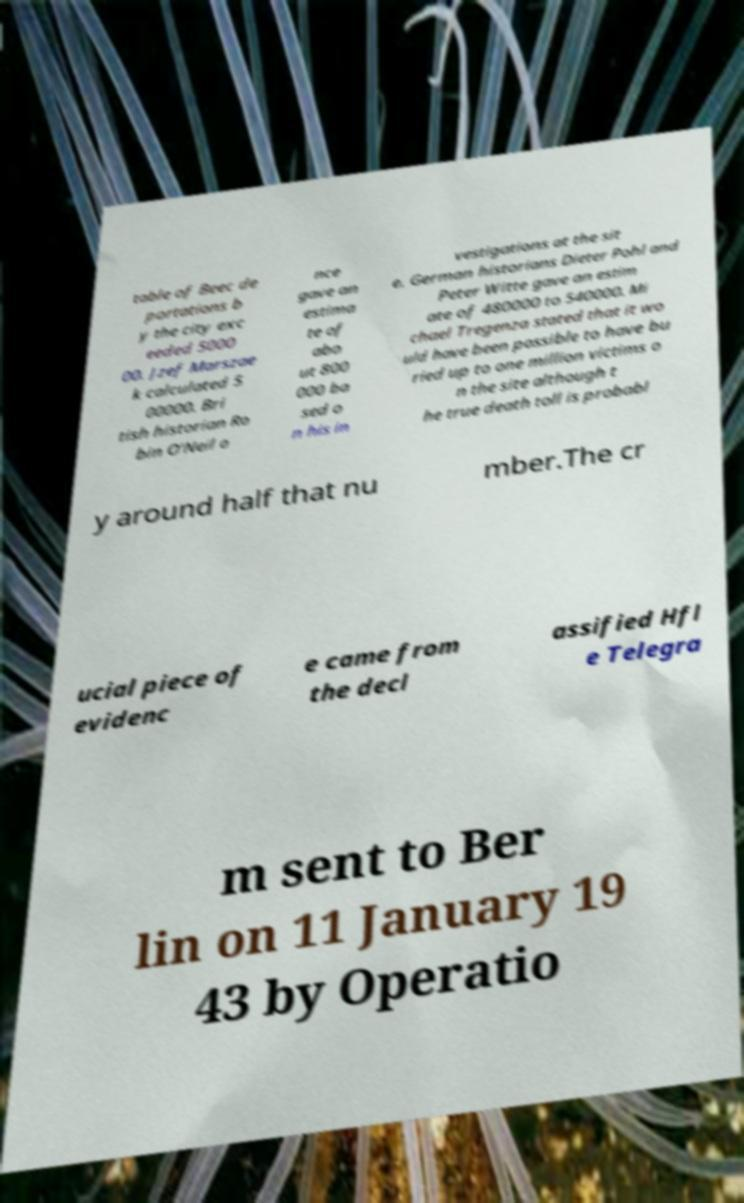Please read and relay the text visible in this image. What does it say? table of Beec de portations b y the city exc eeded 5000 00. Jzef Marszae k calculated 5 00000. Bri tish historian Ro bin O'Neil o nce gave an estima te of abo ut 800 000 ba sed o n his in vestigations at the sit e. German historians Dieter Pohl and Peter Witte gave an estim ate of 480000 to 540000. Mi chael Tregenza stated that it wo uld have been possible to have bu ried up to one million victims o n the site although t he true death toll is probabl y around half that nu mber.The cr ucial piece of evidenc e came from the decl assified Hfl e Telegra m sent to Ber lin on 11 January 19 43 by Operatio 